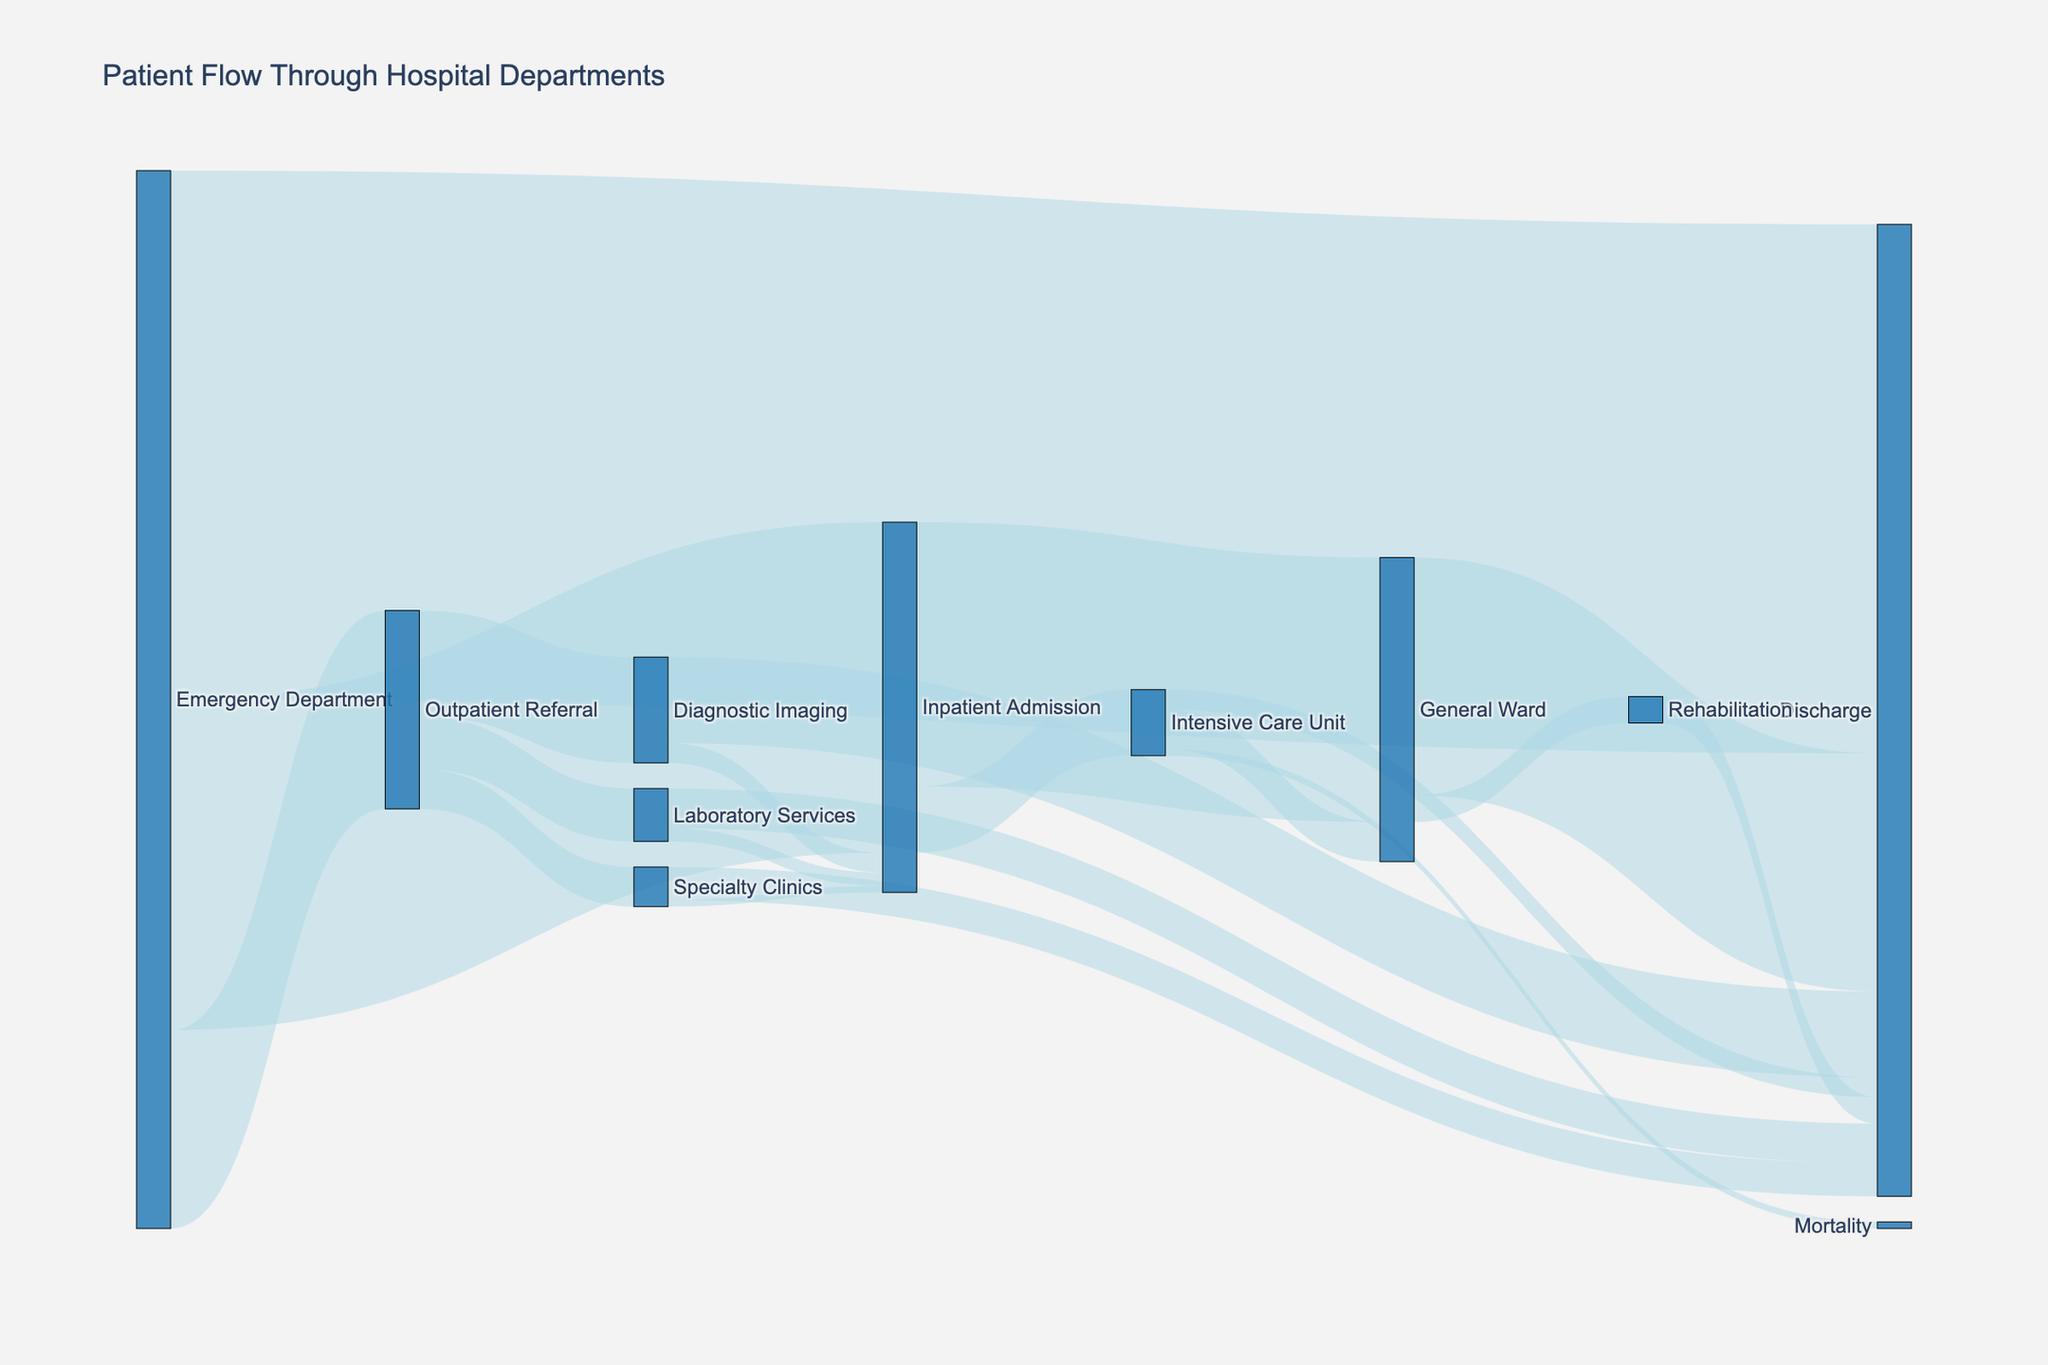What is the title of the figure? The title of a figure is usually located at the top. In this case, the title is "Patient Flow Through Hospital Departments" as indicated in the layout setup of the figure.
Answer: Patient Flow Through Hospital Departments How many patients were discharged directly from the Emergency Department? To find this, look at the flow from the "Emergency Department" to "Discharge". The value next to this flow is 400.
Answer: 400 What is the total number of patients admitted to the Intensive Care Unit? Sum up the values of all flows going into the "Intensive Care Unit" from different sources. The values are 50 (from "Inpatient Admission") and there are no other direct inflows to ICU.
Answer: 50 How many more patients were discharged from Diagnostic Imaging compared to Laboratory Services? First, find the discharge values from both nodes: Diagnostic Imaging has 65, and Laboratory Services has 30. Subtract the latter from the former: 65 - 30.
Answer: 35 Which department has the highest number of patients flowing into it? Compare the sum of all the inflows for each department. Notice the Emergency Department, as it has the highest initial value of 800 (250+400+150) without other competing inflows from outside.
Answer: Emergency Department How many patients transitioned from the General Ward to Rehabilitation? Look for the value of the connection between "General Ward" and "Rehabilitation". It is 20.
Answer: 20 Among patients referred to Specialty Clinics from the Outpatient Referral node, how many were later admitted to the Inpatient Admission? Check the value next to the connection from "Specialty Clinics" to "Inpatient Admission", which is 5.
Answer: 5 Compare the number of patients discharged from the Intensive Care Unit and the Rehabilitation. Which value is higher? Check the discharge flows from each node: "Intensive Care Unit" to "Discharge" is 15 and "Rehabilitation" to "Discharge" is 20. Compare these two values.
Answer: Rehabilitation has a higher discharge flow (20 > 15) If you sum up all the patients who went through Diagnostic Imaging, what total do you get? Add up all the values involving Diagnostic Imaging, including inflows and outflows: 80 + 15 + 65.
Answer: 160 What percentage of patients admitted to the General Ward from the Emergency Department eventually get discharged? Look at the total inflow to the General Ward (200 from "Inpatient Admission" and 30 from "Intensive Care Unit"). Then find how many are discharged from the General Ward (180). Calculate the percentage: (180 / (200 + 30)) * 100. Detailed calculation: 180 out of 230 patients, equals to approximately 78.26%.
Answer: 78.26% 